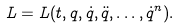Convert formula to latex. <formula><loc_0><loc_0><loc_500><loc_500>L = L ( t , q , \dot { q } , \ddot { q } , \dots , \dot { q } ^ { n } ) .</formula> 